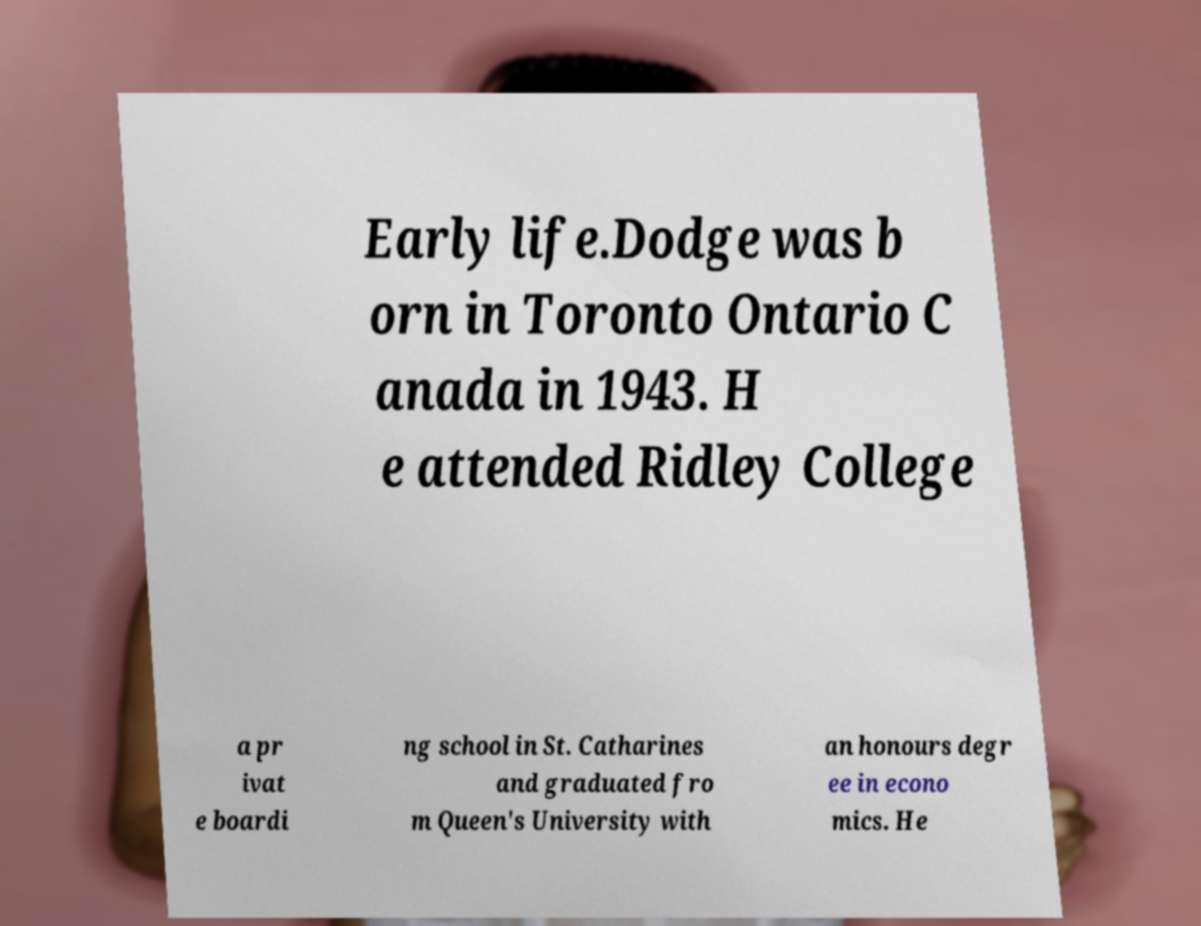There's text embedded in this image that I need extracted. Can you transcribe it verbatim? Early life.Dodge was b orn in Toronto Ontario C anada in 1943. H e attended Ridley College a pr ivat e boardi ng school in St. Catharines and graduated fro m Queen's University with an honours degr ee in econo mics. He 